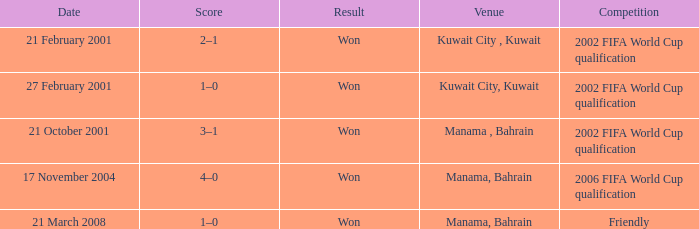Can you parse all the data within this table? {'header': ['Date', 'Score', 'Result', 'Venue', 'Competition'], 'rows': [['21 February 2001', '2–1', 'Won', 'Kuwait City , Kuwait', '2002 FIFA World Cup qualification'], ['27 February 2001', '1–0', 'Won', 'Kuwait City, Kuwait', '2002 FIFA World Cup qualification'], ['21 October 2001', '3–1', 'Won', 'Manama , Bahrain', '2002 FIFA World Cup qualification'], ['17 November 2004', '4–0', 'Won', 'Manama, Bahrain', '2006 FIFA World Cup qualification'], ['21 March 2008', '1–0', 'Won', 'Manama, Bahrain', 'Friendly']]} On which date was the 2006 FIFA World Cup Qualification in Manama, Bahrain? 17 November 2004. 